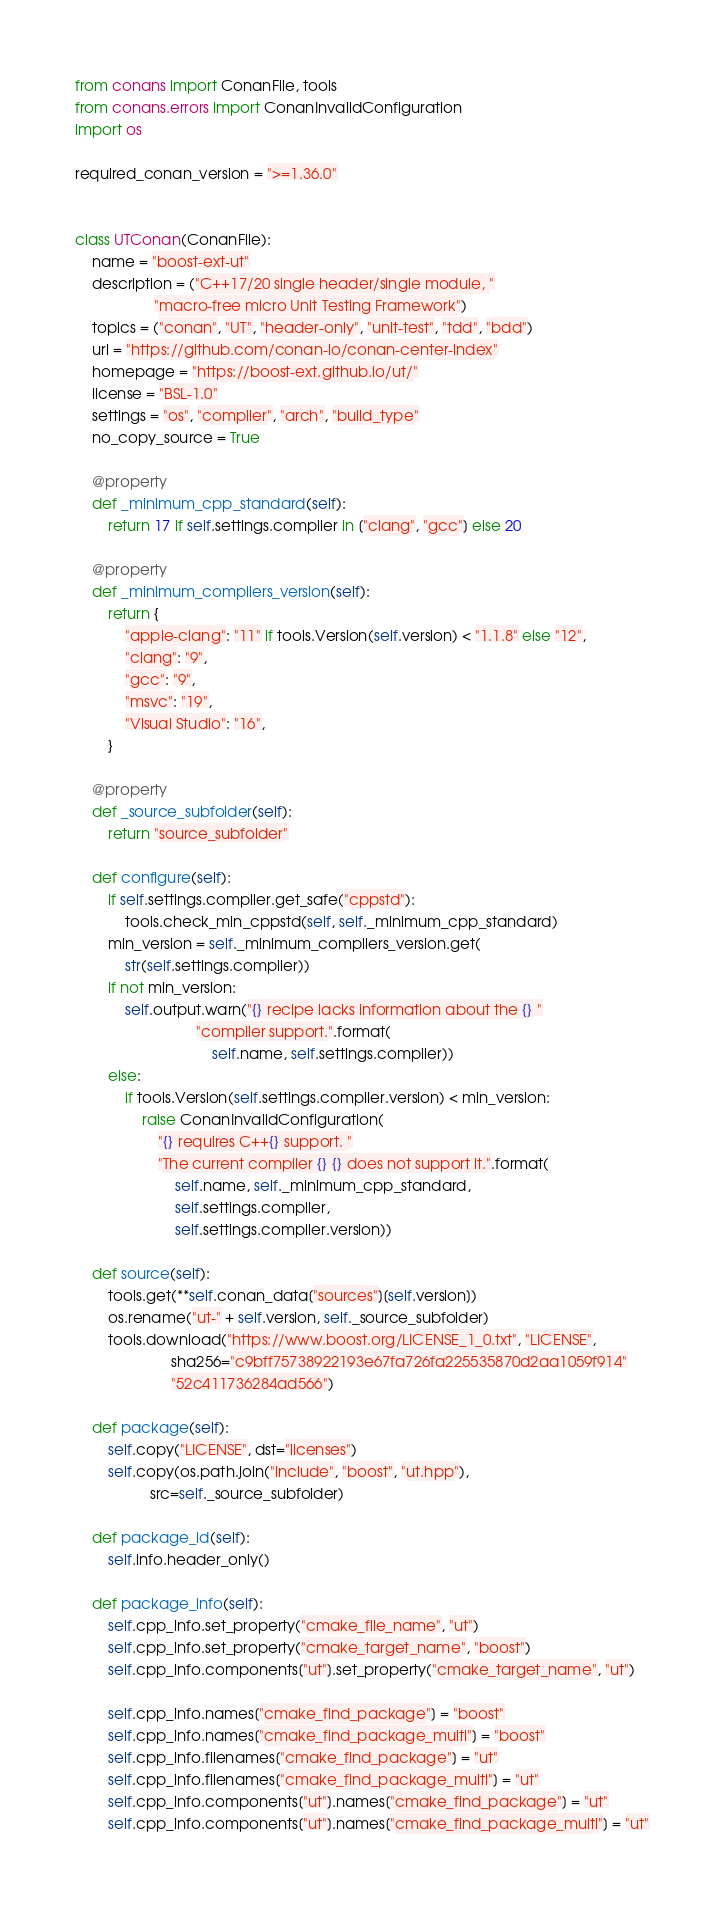<code> <loc_0><loc_0><loc_500><loc_500><_Python_>from conans import ConanFile, tools
from conans.errors import ConanInvalidConfiguration
import os

required_conan_version = ">=1.36.0"


class UTConan(ConanFile):
    name = "boost-ext-ut"
    description = ("C++17/20 single header/single module, "
                   "macro-free micro Unit Testing Framework")
    topics = ("conan", "UT", "header-only", "unit-test", "tdd", "bdd")
    url = "https://github.com/conan-io/conan-center-index"
    homepage = "https://boost-ext.github.io/ut/"
    license = "BSL-1.0"
    settings = "os", "compiler", "arch", "build_type"
    no_copy_source = True

    @property
    def _minimum_cpp_standard(self):
        return 17 if self.settings.compiler in ["clang", "gcc"] else 20

    @property
    def _minimum_compilers_version(self):
        return {
            "apple-clang": "11" if tools.Version(self.version) < "1.1.8" else "12",
            "clang": "9",
            "gcc": "9",
            "msvc": "19",
            "Visual Studio": "16",
        }

    @property
    def _source_subfolder(self):
        return "source_subfolder"

    def configure(self):
        if self.settings.compiler.get_safe("cppstd"):
            tools.check_min_cppstd(self, self._minimum_cpp_standard)
        min_version = self._minimum_compilers_version.get(
            str(self.settings.compiler))
        if not min_version:
            self.output.warn("{} recipe lacks information about the {} "
                             "compiler support.".format(
                                 self.name, self.settings.compiler))
        else:
            if tools.Version(self.settings.compiler.version) < min_version:
                raise ConanInvalidConfiguration(
                    "{} requires C++{} support. "
                    "The current compiler {} {} does not support it.".format(
                        self.name, self._minimum_cpp_standard,
                        self.settings.compiler,
                        self.settings.compiler.version))

    def source(self):
        tools.get(**self.conan_data["sources"][self.version])
        os.rename("ut-" + self.version, self._source_subfolder)
        tools.download("https://www.boost.org/LICENSE_1_0.txt", "LICENSE",
                       sha256="c9bff75738922193e67fa726fa225535870d2aa1059f914"
                       "52c411736284ad566")

    def package(self):
        self.copy("LICENSE", dst="licenses")
        self.copy(os.path.join("include", "boost", "ut.hpp"),
                  src=self._source_subfolder)

    def package_id(self):
        self.info.header_only()

    def package_info(self):
        self.cpp_info.set_property("cmake_file_name", "ut")
        self.cpp_info.set_property("cmake_target_name", "boost")
        self.cpp_info.components["ut"].set_property("cmake_target_name", "ut")

        self.cpp_info.names["cmake_find_package"] = "boost"
        self.cpp_info.names["cmake_find_package_multi"] = "boost"
        self.cpp_info.filenames["cmake_find_package"] = "ut"
        self.cpp_info.filenames["cmake_find_package_multi"] = "ut"
        self.cpp_info.components["ut"].names["cmake_find_package"] = "ut"
        self.cpp_info.components["ut"].names["cmake_find_package_multi"] = "ut"
</code> 